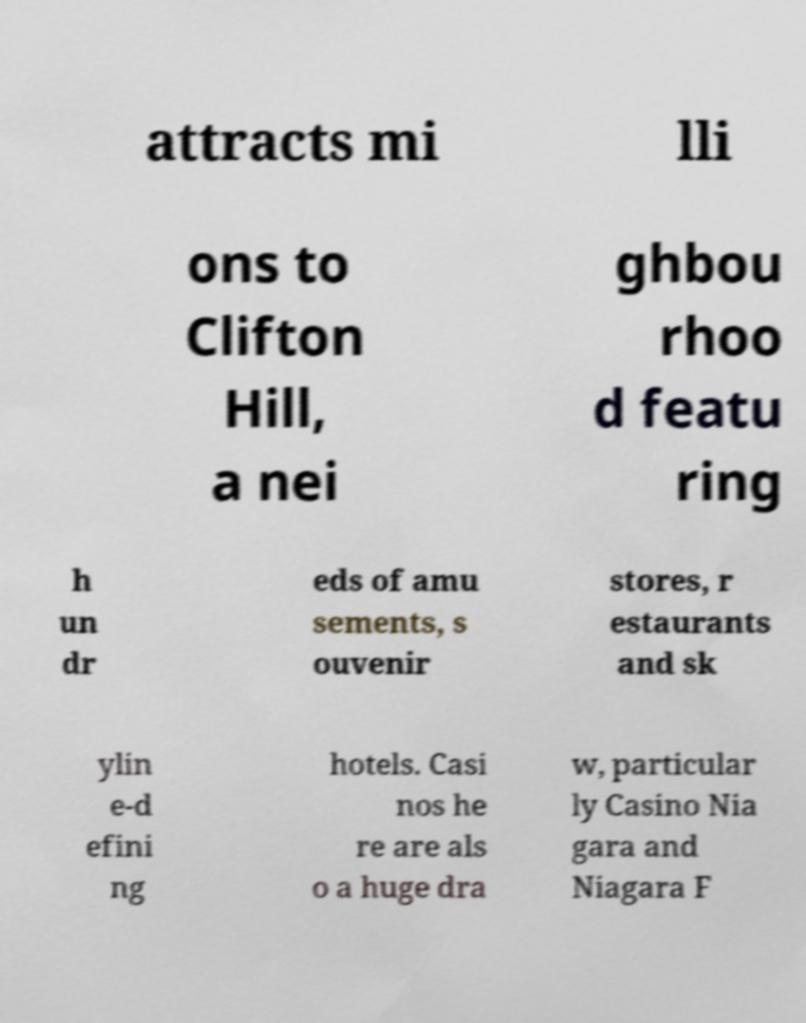Please identify and transcribe the text found in this image. attracts mi lli ons to Clifton Hill, a nei ghbou rhoo d featu ring h un dr eds of amu sements, s ouvenir stores, r estaurants and sk ylin e-d efini ng hotels. Casi nos he re are als o a huge dra w, particular ly Casino Nia gara and Niagara F 